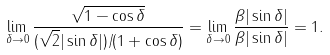<formula> <loc_0><loc_0><loc_500><loc_500>\lim _ { \delta \rightarrow 0 } \frac { \sqrt { 1 - \cos \delta } } { ( \sqrt { 2 } | \sin \delta | ) / ( 1 + \cos \delta ) } = \lim _ { \delta \rightarrow 0 } \frac { \beta | \sin \delta | } { \beta | \sin \delta | } = 1 .</formula> 